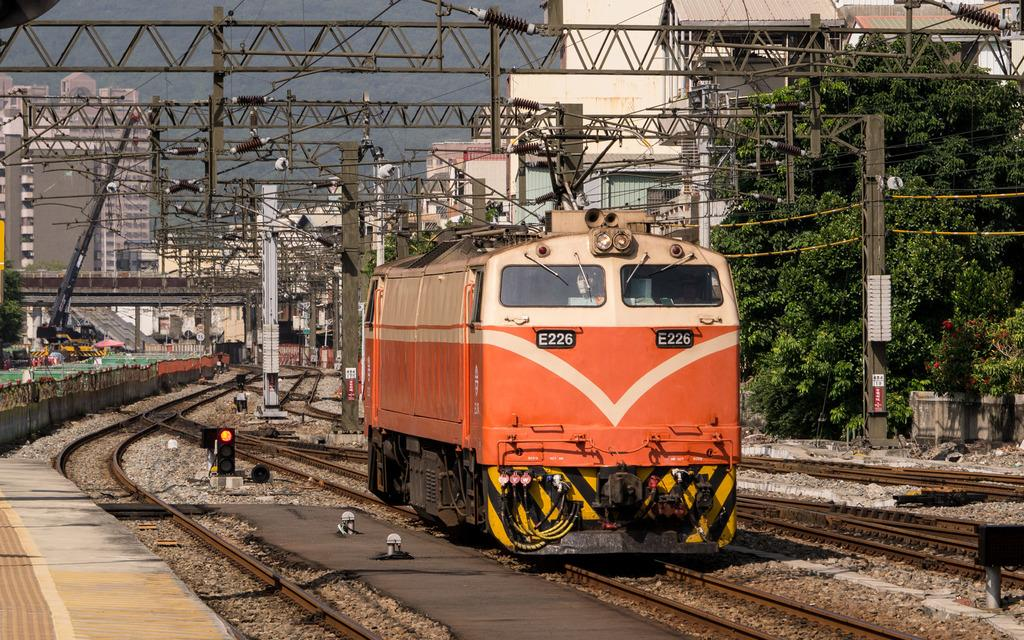<image>
Relay a brief, clear account of the picture shown. A peach and white colored train with E226 on the front of it. 